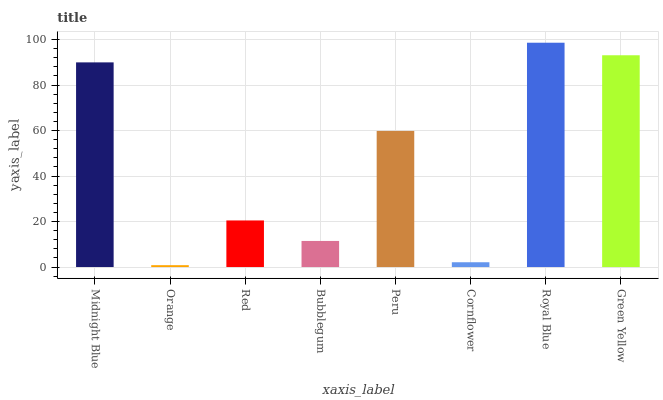Is Orange the minimum?
Answer yes or no. Yes. Is Royal Blue the maximum?
Answer yes or no. Yes. Is Red the minimum?
Answer yes or no. No. Is Red the maximum?
Answer yes or no. No. Is Red greater than Orange?
Answer yes or no. Yes. Is Orange less than Red?
Answer yes or no. Yes. Is Orange greater than Red?
Answer yes or no. No. Is Red less than Orange?
Answer yes or no. No. Is Peru the high median?
Answer yes or no. Yes. Is Red the low median?
Answer yes or no. Yes. Is Cornflower the high median?
Answer yes or no. No. Is Midnight Blue the low median?
Answer yes or no. No. 